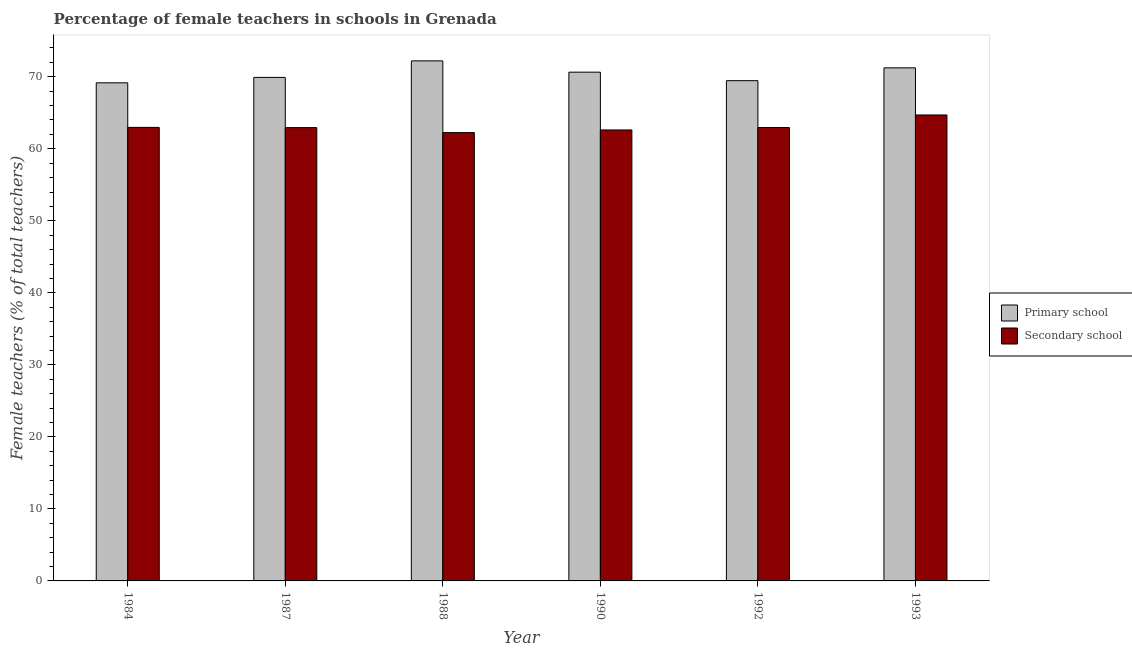How many groups of bars are there?
Ensure brevity in your answer.  6. Are the number of bars per tick equal to the number of legend labels?
Your response must be concise. Yes. Are the number of bars on each tick of the X-axis equal?
Your answer should be compact. Yes. What is the label of the 6th group of bars from the left?
Provide a short and direct response. 1993. What is the percentage of female teachers in secondary schools in 1990?
Keep it short and to the point. 62.62. Across all years, what is the maximum percentage of female teachers in secondary schools?
Offer a very short reply. 64.7. Across all years, what is the minimum percentage of female teachers in secondary schools?
Provide a succinct answer. 62.25. In which year was the percentage of female teachers in secondary schools maximum?
Offer a very short reply. 1993. In which year was the percentage of female teachers in secondary schools minimum?
Give a very brief answer. 1988. What is the total percentage of female teachers in primary schools in the graph?
Your response must be concise. 422.63. What is the difference between the percentage of female teachers in primary schools in 1984 and that in 1990?
Keep it short and to the point. -1.48. What is the difference between the percentage of female teachers in primary schools in 1992 and the percentage of female teachers in secondary schools in 1987?
Give a very brief answer. -0.45. What is the average percentage of female teachers in primary schools per year?
Offer a very short reply. 70.44. What is the ratio of the percentage of female teachers in primary schools in 1987 to that in 1993?
Your response must be concise. 0.98. What is the difference between the highest and the second highest percentage of female teachers in secondary schools?
Make the answer very short. 1.72. What is the difference between the highest and the lowest percentage of female teachers in primary schools?
Give a very brief answer. 3.05. What does the 1st bar from the left in 1988 represents?
Your answer should be compact. Primary school. What does the 2nd bar from the right in 1987 represents?
Provide a short and direct response. Primary school. How many bars are there?
Give a very brief answer. 12. Are all the bars in the graph horizontal?
Offer a very short reply. No. Are the values on the major ticks of Y-axis written in scientific E-notation?
Make the answer very short. No. Does the graph contain grids?
Your answer should be compact. No. How are the legend labels stacked?
Offer a very short reply. Vertical. What is the title of the graph?
Your answer should be compact. Percentage of female teachers in schools in Grenada. Does "Merchandise exports" appear as one of the legend labels in the graph?
Provide a succinct answer. No. What is the label or title of the X-axis?
Make the answer very short. Year. What is the label or title of the Y-axis?
Your answer should be compact. Female teachers (% of total teachers). What is the Female teachers (% of total teachers) of Primary school in 1984?
Provide a succinct answer. 69.16. What is the Female teachers (% of total teachers) in Secondary school in 1984?
Provide a succinct answer. 62.97. What is the Female teachers (% of total teachers) in Primary school in 1987?
Your response must be concise. 69.91. What is the Female teachers (% of total teachers) in Secondary school in 1987?
Offer a terse response. 62.94. What is the Female teachers (% of total teachers) in Primary school in 1988?
Provide a succinct answer. 72.21. What is the Female teachers (% of total teachers) in Secondary school in 1988?
Provide a succinct answer. 62.25. What is the Female teachers (% of total teachers) in Primary school in 1990?
Keep it short and to the point. 70.64. What is the Female teachers (% of total teachers) of Secondary school in 1990?
Provide a succinct answer. 62.62. What is the Female teachers (% of total teachers) in Primary school in 1992?
Your answer should be very brief. 69.46. What is the Female teachers (% of total teachers) of Secondary school in 1992?
Provide a succinct answer. 62.95. What is the Female teachers (% of total teachers) of Primary school in 1993?
Offer a very short reply. 71.24. What is the Female teachers (% of total teachers) in Secondary school in 1993?
Your answer should be compact. 64.7. Across all years, what is the maximum Female teachers (% of total teachers) of Primary school?
Your answer should be very brief. 72.21. Across all years, what is the maximum Female teachers (% of total teachers) in Secondary school?
Your response must be concise. 64.7. Across all years, what is the minimum Female teachers (% of total teachers) of Primary school?
Make the answer very short. 69.16. Across all years, what is the minimum Female teachers (% of total teachers) in Secondary school?
Provide a short and direct response. 62.25. What is the total Female teachers (% of total teachers) of Primary school in the graph?
Provide a short and direct response. 422.63. What is the total Female teachers (% of total teachers) of Secondary school in the graph?
Provide a succinct answer. 378.43. What is the difference between the Female teachers (% of total teachers) of Primary school in 1984 and that in 1987?
Keep it short and to the point. -0.75. What is the difference between the Female teachers (% of total teachers) of Secondary school in 1984 and that in 1987?
Ensure brevity in your answer.  0.03. What is the difference between the Female teachers (% of total teachers) of Primary school in 1984 and that in 1988?
Offer a terse response. -3.05. What is the difference between the Female teachers (% of total teachers) in Secondary school in 1984 and that in 1988?
Ensure brevity in your answer.  0.72. What is the difference between the Female teachers (% of total teachers) of Primary school in 1984 and that in 1990?
Offer a very short reply. -1.48. What is the difference between the Female teachers (% of total teachers) in Secondary school in 1984 and that in 1990?
Ensure brevity in your answer.  0.36. What is the difference between the Female teachers (% of total teachers) in Primary school in 1984 and that in 1992?
Keep it short and to the point. -0.3. What is the difference between the Female teachers (% of total teachers) in Secondary school in 1984 and that in 1992?
Your answer should be very brief. 0.02. What is the difference between the Female teachers (% of total teachers) of Primary school in 1984 and that in 1993?
Give a very brief answer. -2.08. What is the difference between the Female teachers (% of total teachers) in Secondary school in 1984 and that in 1993?
Your answer should be compact. -1.72. What is the difference between the Female teachers (% of total teachers) of Primary school in 1987 and that in 1988?
Provide a succinct answer. -2.29. What is the difference between the Female teachers (% of total teachers) in Secondary school in 1987 and that in 1988?
Make the answer very short. 0.69. What is the difference between the Female teachers (% of total teachers) in Primary school in 1987 and that in 1990?
Your response must be concise. -0.73. What is the difference between the Female teachers (% of total teachers) in Secondary school in 1987 and that in 1990?
Offer a very short reply. 0.32. What is the difference between the Female teachers (% of total teachers) in Primary school in 1987 and that in 1992?
Provide a short and direct response. 0.45. What is the difference between the Female teachers (% of total teachers) of Secondary school in 1987 and that in 1992?
Offer a very short reply. -0.01. What is the difference between the Female teachers (% of total teachers) in Primary school in 1987 and that in 1993?
Provide a succinct answer. -1.32. What is the difference between the Female teachers (% of total teachers) of Secondary school in 1987 and that in 1993?
Make the answer very short. -1.76. What is the difference between the Female teachers (% of total teachers) in Primary school in 1988 and that in 1990?
Your answer should be compact. 1.57. What is the difference between the Female teachers (% of total teachers) in Secondary school in 1988 and that in 1990?
Give a very brief answer. -0.37. What is the difference between the Female teachers (% of total teachers) of Primary school in 1988 and that in 1992?
Provide a short and direct response. 2.75. What is the difference between the Female teachers (% of total teachers) in Secondary school in 1988 and that in 1992?
Keep it short and to the point. -0.7. What is the difference between the Female teachers (% of total teachers) of Secondary school in 1988 and that in 1993?
Your response must be concise. -2.45. What is the difference between the Female teachers (% of total teachers) in Primary school in 1990 and that in 1992?
Offer a terse response. 1.18. What is the difference between the Female teachers (% of total teachers) of Secondary school in 1990 and that in 1992?
Ensure brevity in your answer.  -0.34. What is the difference between the Female teachers (% of total teachers) of Primary school in 1990 and that in 1993?
Make the answer very short. -0.6. What is the difference between the Female teachers (% of total teachers) of Secondary school in 1990 and that in 1993?
Your answer should be compact. -2.08. What is the difference between the Female teachers (% of total teachers) in Primary school in 1992 and that in 1993?
Your answer should be very brief. -1.78. What is the difference between the Female teachers (% of total teachers) in Secondary school in 1992 and that in 1993?
Give a very brief answer. -1.75. What is the difference between the Female teachers (% of total teachers) of Primary school in 1984 and the Female teachers (% of total teachers) of Secondary school in 1987?
Provide a short and direct response. 6.22. What is the difference between the Female teachers (% of total teachers) of Primary school in 1984 and the Female teachers (% of total teachers) of Secondary school in 1988?
Give a very brief answer. 6.91. What is the difference between the Female teachers (% of total teachers) in Primary school in 1984 and the Female teachers (% of total teachers) in Secondary school in 1990?
Provide a succinct answer. 6.54. What is the difference between the Female teachers (% of total teachers) in Primary school in 1984 and the Female teachers (% of total teachers) in Secondary school in 1992?
Give a very brief answer. 6.21. What is the difference between the Female teachers (% of total teachers) in Primary school in 1984 and the Female teachers (% of total teachers) in Secondary school in 1993?
Give a very brief answer. 4.46. What is the difference between the Female teachers (% of total teachers) of Primary school in 1987 and the Female teachers (% of total teachers) of Secondary school in 1988?
Make the answer very short. 7.67. What is the difference between the Female teachers (% of total teachers) of Primary school in 1987 and the Female teachers (% of total teachers) of Secondary school in 1990?
Keep it short and to the point. 7.3. What is the difference between the Female teachers (% of total teachers) in Primary school in 1987 and the Female teachers (% of total teachers) in Secondary school in 1992?
Offer a very short reply. 6.96. What is the difference between the Female teachers (% of total teachers) in Primary school in 1987 and the Female teachers (% of total teachers) in Secondary school in 1993?
Make the answer very short. 5.22. What is the difference between the Female teachers (% of total teachers) of Primary school in 1988 and the Female teachers (% of total teachers) of Secondary school in 1990?
Your answer should be compact. 9.59. What is the difference between the Female teachers (% of total teachers) of Primary school in 1988 and the Female teachers (% of total teachers) of Secondary school in 1992?
Offer a very short reply. 9.26. What is the difference between the Female teachers (% of total teachers) of Primary school in 1988 and the Female teachers (% of total teachers) of Secondary school in 1993?
Your answer should be very brief. 7.51. What is the difference between the Female teachers (% of total teachers) of Primary school in 1990 and the Female teachers (% of total teachers) of Secondary school in 1992?
Provide a short and direct response. 7.69. What is the difference between the Female teachers (% of total teachers) in Primary school in 1990 and the Female teachers (% of total teachers) in Secondary school in 1993?
Offer a very short reply. 5.94. What is the difference between the Female teachers (% of total teachers) of Primary school in 1992 and the Female teachers (% of total teachers) of Secondary school in 1993?
Offer a very short reply. 4.76. What is the average Female teachers (% of total teachers) of Primary school per year?
Offer a terse response. 70.44. What is the average Female teachers (% of total teachers) of Secondary school per year?
Ensure brevity in your answer.  63.07. In the year 1984, what is the difference between the Female teachers (% of total teachers) in Primary school and Female teachers (% of total teachers) in Secondary school?
Offer a terse response. 6.19. In the year 1987, what is the difference between the Female teachers (% of total teachers) in Primary school and Female teachers (% of total teachers) in Secondary school?
Keep it short and to the point. 6.97. In the year 1988, what is the difference between the Female teachers (% of total teachers) of Primary school and Female teachers (% of total teachers) of Secondary school?
Keep it short and to the point. 9.96. In the year 1990, what is the difference between the Female teachers (% of total teachers) in Primary school and Female teachers (% of total teachers) in Secondary school?
Give a very brief answer. 8.03. In the year 1992, what is the difference between the Female teachers (% of total teachers) of Primary school and Female teachers (% of total teachers) of Secondary school?
Give a very brief answer. 6.51. In the year 1993, what is the difference between the Female teachers (% of total teachers) of Primary school and Female teachers (% of total teachers) of Secondary school?
Your answer should be compact. 6.54. What is the ratio of the Female teachers (% of total teachers) of Primary school in 1984 to that in 1987?
Provide a succinct answer. 0.99. What is the ratio of the Female teachers (% of total teachers) of Secondary school in 1984 to that in 1987?
Offer a terse response. 1. What is the ratio of the Female teachers (% of total teachers) of Primary school in 1984 to that in 1988?
Provide a short and direct response. 0.96. What is the ratio of the Female teachers (% of total teachers) of Secondary school in 1984 to that in 1988?
Keep it short and to the point. 1.01. What is the ratio of the Female teachers (% of total teachers) in Primary school in 1984 to that in 1990?
Provide a short and direct response. 0.98. What is the ratio of the Female teachers (% of total teachers) of Primary school in 1984 to that in 1993?
Provide a succinct answer. 0.97. What is the ratio of the Female teachers (% of total teachers) of Secondary school in 1984 to that in 1993?
Your answer should be compact. 0.97. What is the ratio of the Female teachers (% of total teachers) of Primary school in 1987 to that in 1988?
Give a very brief answer. 0.97. What is the ratio of the Female teachers (% of total teachers) of Secondary school in 1987 to that in 1988?
Provide a succinct answer. 1.01. What is the ratio of the Female teachers (% of total teachers) of Primary school in 1987 to that in 1990?
Make the answer very short. 0.99. What is the ratio of the Female teachers (% of total teachers) in Secondary school in 1987 to that in 1990?
Your response must be concise. 1.01. What is the ratio of the Female teachers (% of total teachers) in Primary school in 1987 to that in 1992?
Ensure brevity in your answer.  1.01. What is the ratio of the Female teachers (% of total teachers) of Secondary school in 1987 to that in 1992?
Make the answer very short. 1. What is the ratio of the Female teachers (% of total teachers) of Primary school in 1987 to that in 1993?
Ensure brevity in your answer.  0.98. What is the ratio of the Female teachers (% of total teachers) in Secondary school in 1987 to that in 1993?
Offer a very short reply. 0.97. What is the ratio of the Female teachers (% of total teachers) in Primary school in 1988 to that in 1990?
Provide a succinct answer. 1.02. What is the ratio of the Female teachers (% of total teachers) of Secondary school in 1988 to that in 1990?
Your response must be concise. 0.99. What is the ratio of the Female teachers (% of total teachers) of Primary school in 1988 to that in 1992?
Your answer should be compact. 1.04. What is the ratio of the Female teachers (% of total teachers) in Primary school in 1988 to that in 1993?
Provide a succinct answer. 1.01. What is the ratio of the Female teachers (% of total teachers) of Secondary school in 1988 to that in 1993?
Offer a very short reply. 0.96. What is the ratio of the Female teachers (% of total teachers) of Secondary school in 1990 to that in 1993?
Offer a terse response. 0.97. What is the ratio of the Female teachers (% of total teachers) in Secondary school in 1992 to that in 1993?
Provide a short and direct response. 0.97. What is the difference between the highest and the second highest Female teachers (% of total teachers) in Primary school?
Provide a succinct answer. 0.97. What is the difference between the highest and the second highest Female teachers (% of total teachers) of Secondary school?
Keep it short and to the point. 1.72. What is the difference between the highest and the lowest Female teachers (% of total teachers) of Primary school?
Offer a very short reply. 3.05. What is the difference between the highest and the lowest Female teachers (% of total teachers) of Secondary school?
Your answer should be compact. 2.45. 